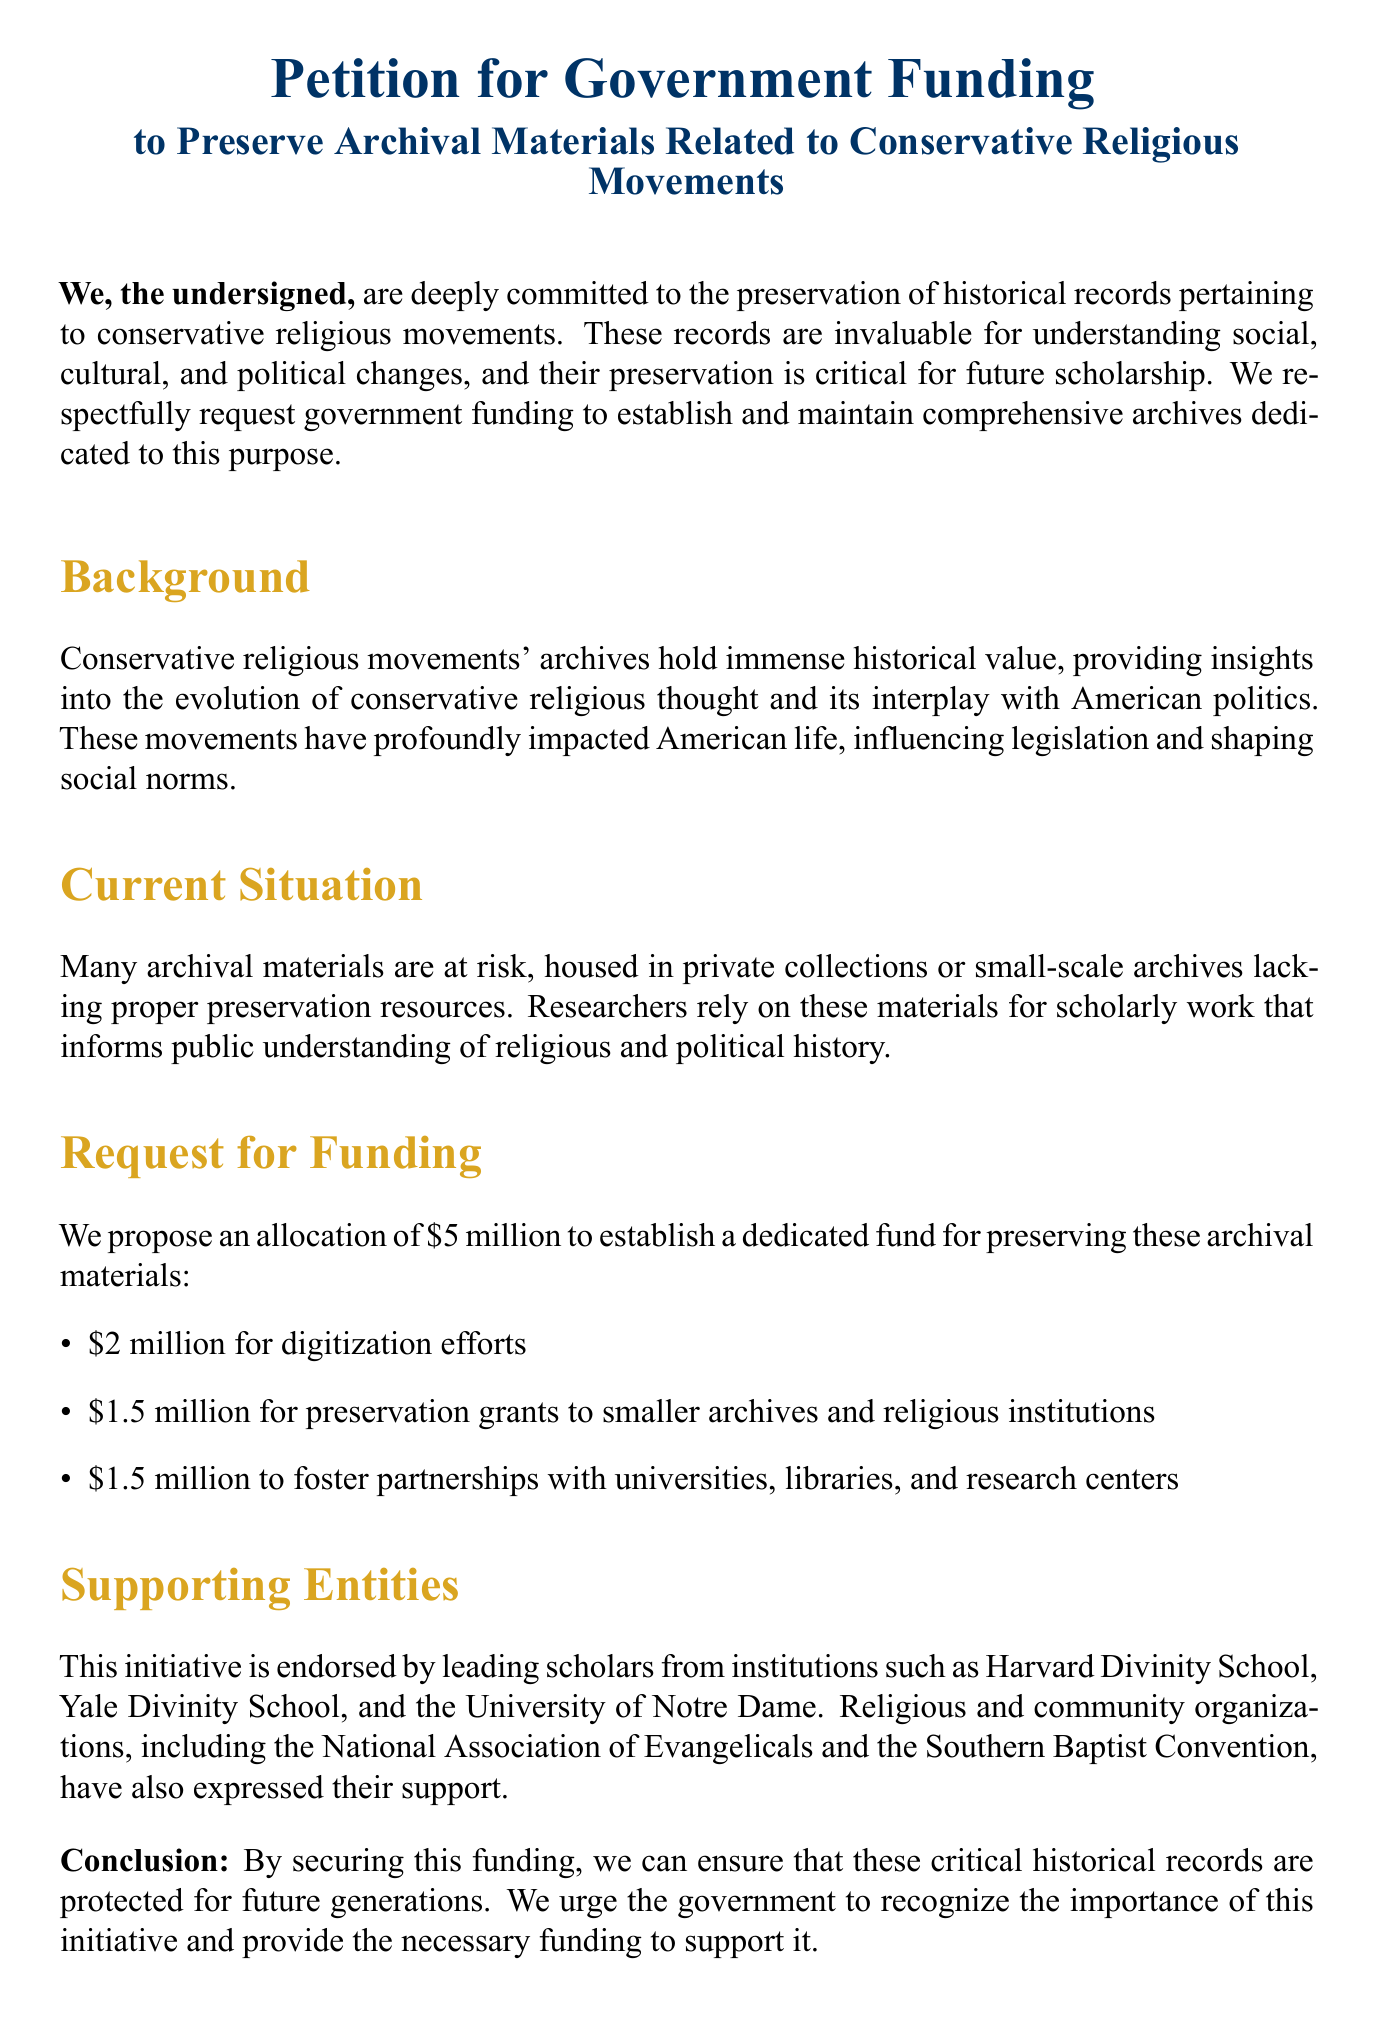what is the petition about? The petition requests government funding to preserve archival materials related to conservative religious movements.
Answer: government funding to preserve archival materials who are the supporting entities mentioned? The supporting entities include leading scholars and religious organizations such as the National Association of Evangelicals and the Southern Baptist Convention.
Answer: leading scholars, National Association of Evangelicals, Southern Baptist Convention how much funding is proposed for digitization efforts? The document specifies $2 million for digitization efforts as part of the funding request.
Answer: $2 million what is the total proposed allocation for the funding request? The total proposed allocation is the sum of all proposed funds for various purposes: $5 million (2 million, 1.5 million, 1.5 million).
Answer: $5 million what is the significance of preserving these archival materials? The significance lies in their value for understanding social, cultural, and political changes, and their impact on American history.
Answer: understanding social, cultural, and political changes what is the date format implied in the document for signatures? The document includes a section for signatures along with a space for dates, suggesting a date format following the signature.
Answer: Date what is mentioned as a current situation regarding archival materials? The current situation is that many archival materials are at risk due to being housed in private collections or small-scale archives lacking resources.
Answer: at risk what is one of the goals of the proposed funding? One of the goals of the proposed funding is to foster partnerships with universities, libraries, and research centers.
Answer: foster partnerships what is the concluding statement of the petition? The concluding statement urges the government to recognize the importance of the initiative and provide the necessary funding.
Answer: recognize the importance of this initiative and provide the necessary funding 